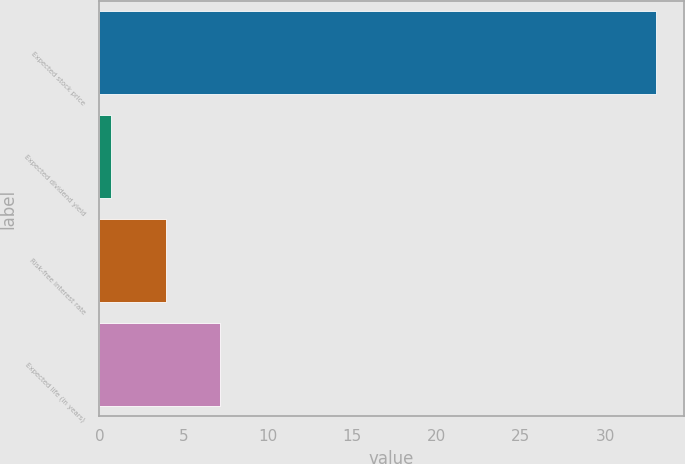<chart> <loc_0><loc_0><loc_500><loc_500><bar_chart><fcel>Expected stock price<fcel>Expected dividend yield<fcel>Risk-free interest rate<fcel>Expected life (in years)<nl><fcel>33<fcel>0.7<fcel>3.93<fcel>7.16<nl></chart> 